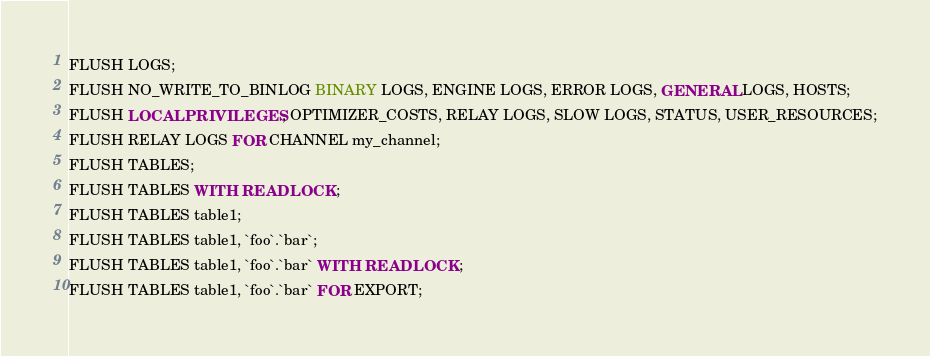<code> <loc_0><loc_0><loc_500><loc_500><_SQL_>FLUSH LOGS;
FLUSH NO_WRITE_TO_BINLOG BINARY LOGS, ENGINE LOGS, ERROR LOGS, GENERAL LOGS, HOSTS;
FLUSH LOCAL PRIVILEGES, OPTIMIZER_COSTS, RELAY LOGS, SLOW LOGS, STATUS, USER_RESOURCES;
FLUSH RELAY LOGS FOR CHANNEL my_channel;
FLUSH TABLES;
FLUSH TABLES WITH READ LOCK;
FLUSH TABLES table1;
FLUSH TABLES table1, `foo`.`bar`;
FLUSH TABLES table1, `foo`.`bar` WITH READ LOCK;
FLUSH TABLES table1, `foo`.`bar` FOR EXPORT;
</code> 